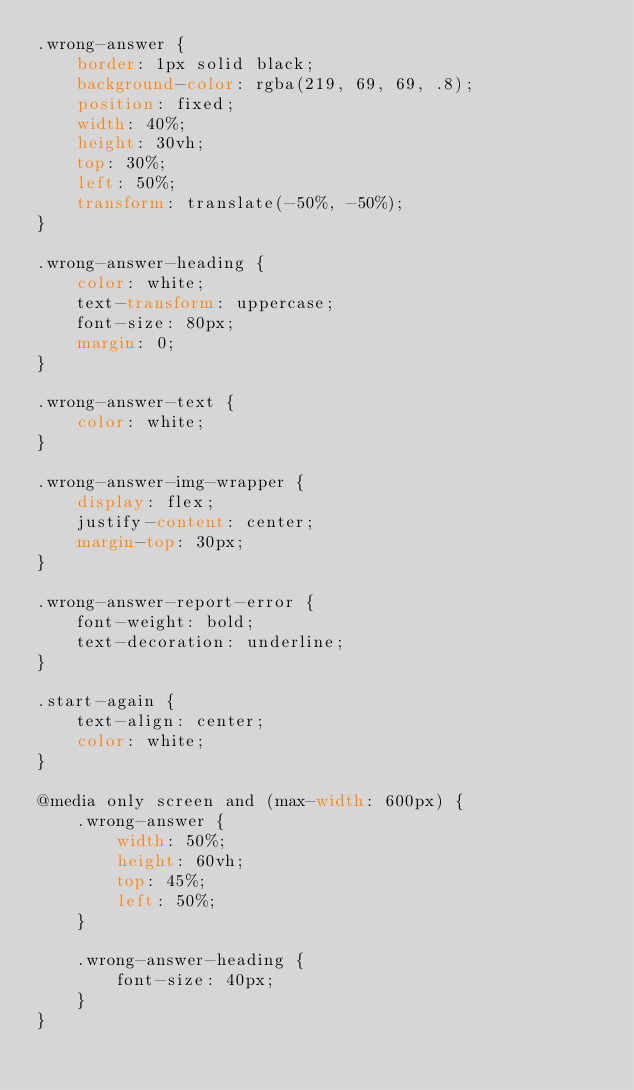<code> <loc_0><loc_0><loc_500><loc_500><_CSS_>.wrong-answer {
    border: 1px solid black;
    background-color: rgba(219, 69, 69, .8);
    position: fixed;
    width: 40%;
    height: 30vh;
    top: 30%;
    left: 50%;
    transform: translate(-50%, -50%);
}

.wrong-answer-heading {
    color: white;
    text-transform: uppercase;
    font-size: 80px;
    margin: 0;
}

.wrong-answer-text {
    color: white;
}

.wrong-answer-img-wrapper {
    display: flex;
    justify-content: center;
    margin-top: 30px;
}

.wrong-answer-report-error {
    font-weight: bold;
    text-decoration: underline;
}

.start-again {
    text-align: center;
    color: white;
}

@media only screen and (max-width: 600px) {
    .wrong-answer {
        width: 50%;
        height: 60vh;
        top: 45%;
        left: 50%;
    }

    .wrong-answer-heading {
        font-size: 40px;
    }
}</code> 